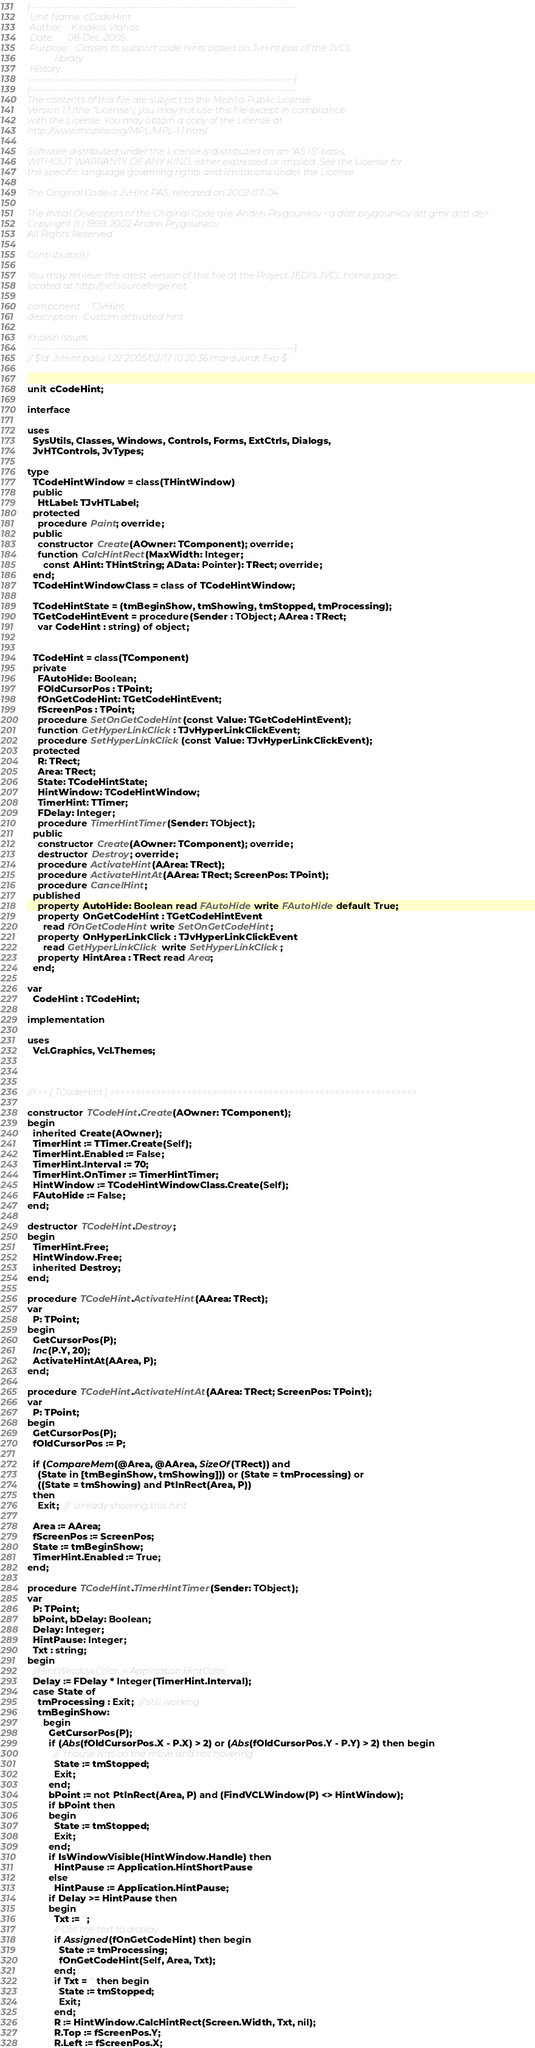Convert code to text. <code><loc_0><loc_0><loc_500><loc_500><_Pascal_>{-----------------------------------------------------------------------------
 Unit Name: cCodeHint
 Author:    Kiriakos Vlahos
 Date:      08-Dec-2005
 Purpose:   Classes to support code hints based on JvHint.pas of the JVCL
            library
 History:
-----------------------------------------------------------------------------}
{-----------------------------------------------------------------------------
The contents of this file are subject to the Mozilla Public License
Version 1.1 (the "License"); you may not use this file except in compliance
with the License. You may obtain a copy of the License at
http://www.mozilla.org/MPL/MPL-1.1.html

Software distributed under the License is distributed on an "AS IS" basis,
WITHOUT WARRANTY OF ANY KIND, either expressed or implied. See the License for
the specific language governing rights and limitations under the License.

The Original Code is: JvHint.PAS, released on 2002-07-04.

The Initial Developers of the Original Code are: Andrei Prygounkov <a dott prygounkov att gmx dott de>
Copyright (c) 1999, 2002 Andrei Prygounkov
All Rights Reserved.

Contributor(s):

You may retrieve the latest version of this file at the Project JEDI's JVCL home page,
located at http://jvcl.sourceforge.net

component   : TJvHint
description : Custom activated hint

Known Issues:
-----------------------------------------------------------------------------}
// $Id: JvHint.pas,v 1.22 2005/02/17 10:20:36 marquardt Exp $


unit cCodeHint;

interface

uses
  SysUtils, Classes, Windows, Controls, Forms, ExtCtrls, Dialogs,
  JvHTControls, JvTypes;

type
  TCodeHintWindow = class(THintWindow)
  public
    HtLabel: TJvHTLabel;
  protected
    procedure Paint; override;
  public
    constructor Create(AOwner: TComponent); override;
    function CalcHintRect(MaxWidth: Integer;
      const AHint: THintString; AData: Pointer): TRect; override;
  end;
  TCodeHintWindowClass = class of TCodeHintWindow;

  TCodeHintState = (tmBeginShow, tmShowing, tmStopped, tmProcessing);
  TGetCodeHintEvent = procedure(Sender : TObject; AArea : TRect;
    var CodeHint : string) of object;


  TCodeHint = class(TComponent)
  private
    FAutoHide: Boolean;
    FOldCursorPos : TPoint;
    fOnGetCodeHint: TGetCodeHintEvent;
    fScreenPos : TPoint;
    procedure SetOnGetCodeHint(const Value: TGetCodeHintEvent);
    function GetHyperLinkClick: TJvHyperLinkClickEvent;
    procedure SetHyperLinkClick(const Value: TJvHyperLinkClickEvent);
  protected
    R: TRect;
    Area: TRect;
    State: TCodeHintState;
    HintWindow: TCodeHintWindow;
    TimerHint: TTimer;
    FDelay: Integer;
    procedure TimerHintTimer(Sender: TObject);
  public
    constructor Create(AOwner: TComponent); override;
    destructor Destroy; override;
    procedure ActivateHint(AArea: TRect);
    procedure ActivateHintAt(AArea: TRect; ScreenPos: TPoint);
    procedure CancelHint;
  published
    property AutoHide: Boolean read FAutoHide write FAutoHide default True;
    property OnGetCodeHint : TGetCodeHintEvent
      read fOnGetCodeHint write SetOnGetCodeHint;
    property OnHyperLinkClick : TJvHyperLinkClickEvent
      read GetHyperLinkClick write SetHyperLinkClick;
    property HintArea : TRect read Area;
  end;

var
  CodeHint : TCodeHint;

implementation

uses
  Vcl.Graphics, Vcl.Themes;



//=== { TCodeHint } ============================================================

constructor TCodeHint.Create(AOwner: TComponent);
begin
  inherited Create(AOwner);
  TimerHint := TTimer.Create(Self);
  TimerHint.Enabled := False;
  TimerHint.Interval := 70;
  TimerHint.OnTimer := TimerHintTimer;
  HintWindow := TCodeHintWindowClass.Create(Self);
  FAutoHide := False;
end;

destructor TCodeHint.Destroy;
begin
  TimerHint.Free;
  HintWindow.Free;
  inherited Destroy;
end;

procedure TCodeHint.ActivateHint(AArea: TRect);
var
  P: TPoint;
begin
  GetCursorPos(P);
  Inc(P.Y, 20);
  ActivateHintAt(AArea, P);
end;

procedure TCodeHint.ActivateHintAt(AArea: TRect; ScreenPos: TPoint);
var
  P: TPoint;
begin
  GetCursorPos(P);
  fOldCursorPos := P;

  if (CompareMem(@Area, @AArea, SizeOf(TRect)) and
    (State in [tmBeginShow, tmShowing])) or (State = tmProcessing) or
    ((State = tmShowing) and PtInRect(Area, P))
  then
    Exit;  //  already showing this hint

  Area := AArea;
  fScreenPos := ScreenPos;
  State := tmBeginShow;
  TimerHint.Enabled := True;
end;

procedure TCodeHint.TimerHintTimer(Sender: TObject);
var
  P: TPoint;
  bPoint, bDelay: Boolean;
  Delay: Integer;
  HintPause: Integer;
  Txt : string;
begin
  //HintWindow.Color := Application.HintColor;
  Delay := FDelay * Integer(TimerHint.Interval);
  case State of
    tmProcessing : Exit;  // still working
    tmBeginShow:
      begin
        GetCursorPos(P);
        if (Abs(fOldCursorPos.X - P.X) > 2) or (Abs(fOldCursorPos.Y - P.Y) > 2) then begin
          //  mouse was on the move and not hovering
          State := tmStopped;
          Exit;
        end;
        bPoint := not PtInRect(Area, P) and (FindVCLWindow(P) <> HintWindow);
        if bPoint then
        begin
          State := tmStopped;
          Exit;
        end;
        if IsWindowVisible(HintWindow.Handle) then
          HintPause := Application.HintShortPause
        else
          HintPause := Application.HintPause;
        if Delay >= HintPause then
        begin
          Txt := '';
          // Get the text to display
          if Assigned(fOnGetCodeHint) then begin
            State := tmProcessing;
            fOnGetCodeHint(Self, Area, Txt);
          end;
          if Txt = '' then begin
            State := tmStopped;
            Exit;
          end;
          R := HintWindow.CalcHintRect(Screen.Width, Txt, nil);
          R.Top := fScreenPos.Y;
          R.Left := fScreenPos.X;</code> 